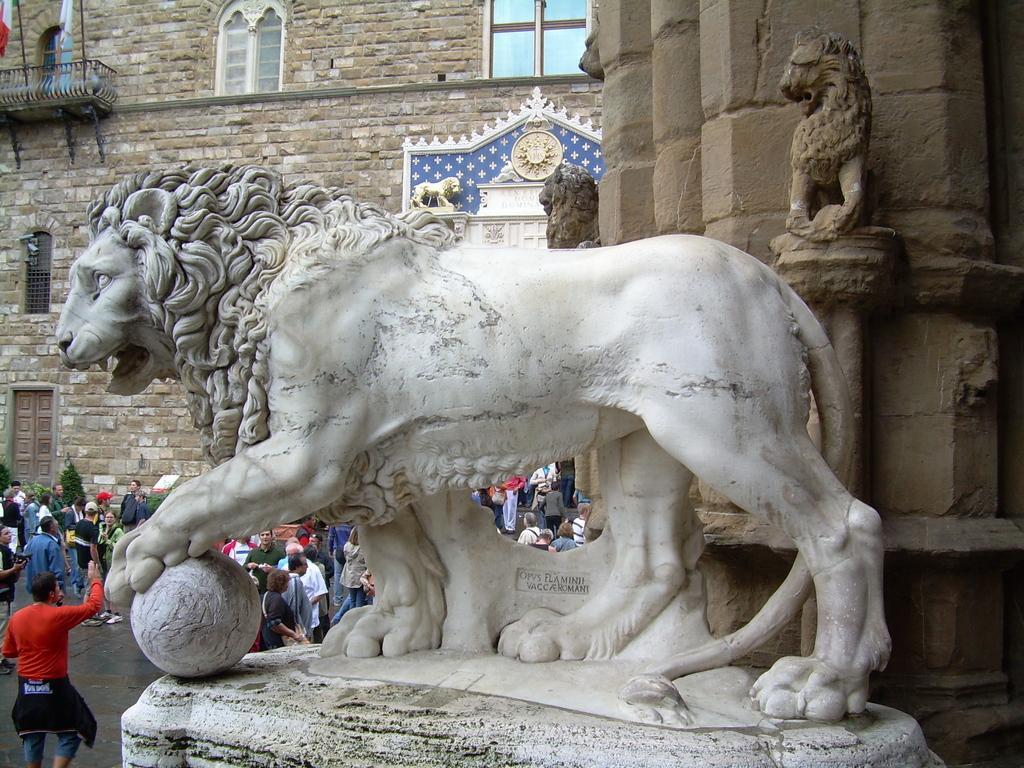How would you summarize this image in a sentence or two? In this picture we can see a statue of an animal on the platform and in the background we can see a building, people, trees and some object. 